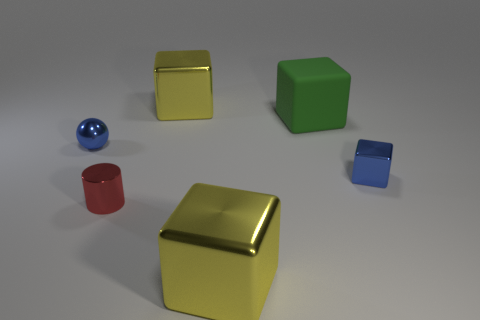How many yellow blocks must be subtracted to get 1 yellow blocks? 1 Subtract all tiny cubes. How many cubes are left? 3 Subtract 1 blocks. How many blocks are left? 3 Add 4 big yellow rubber spheres. How many objects exist? 10 Subtract all green blocks. How many blocks are left? 3 Subtract all cylinders. How many objects are left? 5 Subtract all brown cubes. Subtract all yellow cylinders. How many cubes are left? 4 Subtract all gray spheres. How many cyan cubes are left? 0 Subtract all small yellow matte balls. Subtract all small blue balls. How many objects are left? 5 Add 6 green matte objects. How many green matte objects are left? 7 